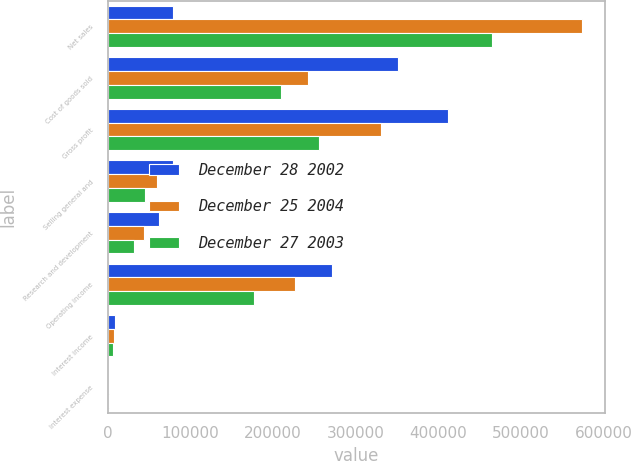<chart> <loc_0><loc_0><loc_500><loc_500><stacked_bar_chart><ecel><fcel>Net sales<fcel>Cost of goods sold<fcel>Gross profit<fcel>Selling general and<fcel>Research and development<fcel>Operating income<fcel>Interest income<fcel>Interest expense<nl><fcel>December 28 2002<fcel>78991<fcel>351310<fcel>411239<fcel>78991<fcel>61580<fcel>270668<fcel>9419<fcel>38<nl><fcel>December 25 2004<fcel>572989<fcel>242448<fcel>330541<fcel>59835<fcel>43706<fcel>227000<fcel>7473<fcel>534<nl><fcel>December 27 2003<fcel>465144<fcel>210088<fcel>255056<fcel>45453<fcel>32163<fcel>177440<fcel>6466<fcel>1329<nl></chart> 